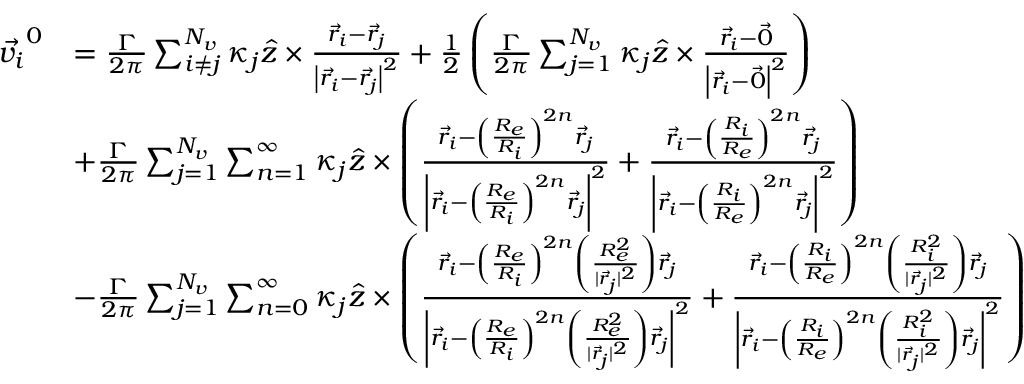Convert formula to latex. <formula><loc_0><loc_0><loc_500><loc_500>\begin{array} { r l } { \vec { v _ { i } } ^ { 0 } } & { = \frac { \Gamma } { 2 \pi } \sum _ { i \neq j } ^ { N _ { v } } \kappa _ { j } \hat { z } \times \frac { \vec { r } _ { i } - \vec { r } _ { j } } { \left | \vec { r } _ { i } - \vec { r } _ { j } \right | ^ { 2 } } + \frac { 1 } { 2 } \left ( \frac { \Gamma } { 2 \pi } \sum _ { j = 1 } ^ { N _ { v } } \kappa _ { j } \hat { z } \times \frac { \vec { r } _ { i } - \vec { 0 } } { \left | \vec { r } _ { i } - \vec { 0 } \right | ^ { 2 } } \right ) } \\ & { + \frac { \Gamma } { 2 \pi } \sum _ { j = 1 } ^ { N _ { v } } \sum _ { n = 1 } ^ { \infty } \kappa _ { j } \hat { z } \times \left ( \frac { \vec { r } _ { i } - \left ( \frac { R _ { e } } { R _ { i } } \right ) ^ { 2 n } \vec { r } _ { j } } { \left | \vec { r } _ { i } - \left ( \frac { R _ { e } } { R _ { i } } \right ) ^ { 2 n } \vec { r } _ { j } \right | ^ { 2 } } + \frac { \vec { r } _ { i } - \left ( \frac { R _ { i } } { R _ { e } } \right ) ^ { 2 n } \vec { r } _ { j } } { \left | \vec { r } _ { i } - \left ( \frac { R _ { i } } { R _ { e } } \right ) ^ { 2 n } \vec { r } _ { j } \right | ^ { 2 } } \right ) } \\ & { - \frac { \Gamma } { 2 \pi } \sum _ { j = 1 } ^ { N _ { v } } \sum _ { n = 0 } ^ { \infty } \kappa _ { j } \hat { z } \times \left ( \frac { \vec { r } _ { i } - \left ( \frac { R _ { e } } { R _ { i } } \right ) ^ { 2 n } \left ( \frac { R _ { e } ^ { 2 } } { | \vec { r } _ { j } | ^ { 2 } } \right ) \vec { r } _ { j } } { \left | \vec { r } _ { i } - \left ( \frac { R _ { e } } { R _ { i } } \right ) ^ { 2 n } \left ( \frac { R _ { e } ^ { 2 } } { | \vec { r } _ { j } | ^ { 2 } } \right ) \vec { r } _ { j } \right | ^ { 2 } } + \frac { \vec { r } _ { i } - \left ( \frac { R _ { i } } { R _ { e } } \right ) ^ { 2 n } \left ( \frac { R _ { i } ^ { 2 } } { | \vec { r } _ { j } | ^ { 2 } } \right ) \vec { r } _ { j } } { \left | \vec { r } _ { i } - \left ( \frac { R _ { i } } { R _ { e } } \right ) ^ { 2 n } \left ( \frac { R _ { i } ^ { 2 } } { | \vec { r } _ { j } | ^ { 2 } } \right ) \vec { r } _ { j } \right | ^ { 2 } } \right ) } \end{array}</formula> 